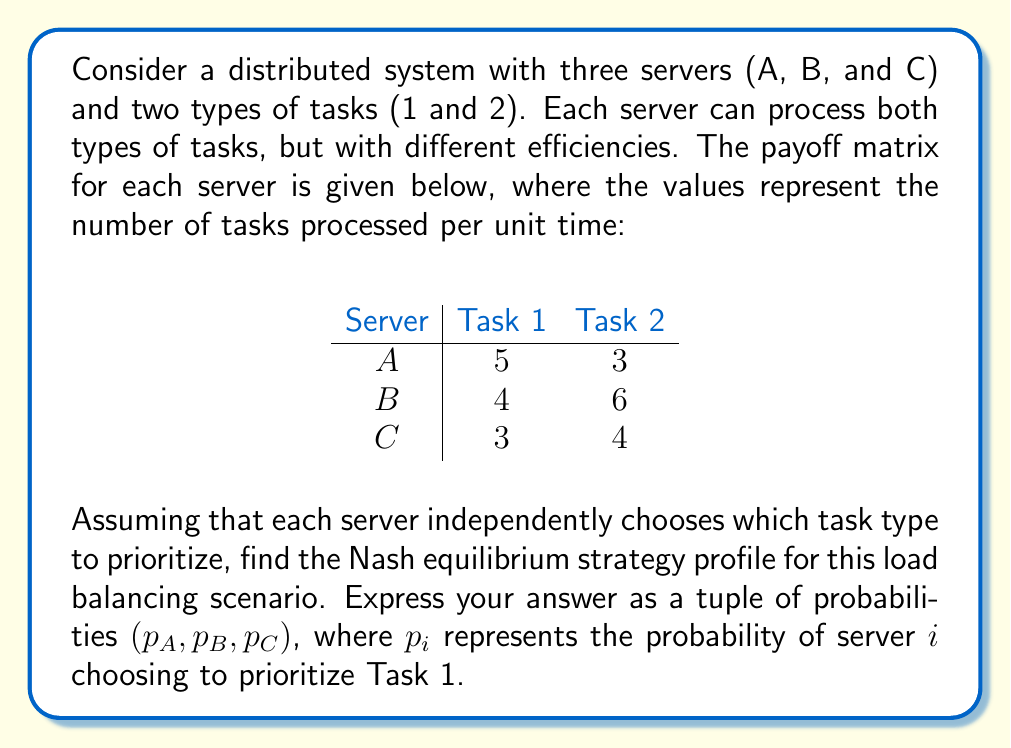Give your solution to this math problem. To solve this problem, we need to find the Nash equilibrium where no server has an incentive to unilaterally change its strategy. We'll use the concept of mixed strategies to find this equilibrium.

1. First, let's set up the expected payoff equations for each server:

   For Server A: $5p_A + 3(1-p_A) = 3p_A + 3$
   For Server B: $4p_B + 6(1-p_B) = 6 - 2p_B$
   For Server C: $3p_C + 4(1-p_C) = 4 - p_C$

2. In a mixed strategy Nash equilibrium, each server should be indifferent between choosing Task 1 or Task 2. This means the expected payoffs for choosing either task should be equal:

   For Server A: $5p_B + 5p_C = 3p_B + 3p_C + 3$
   For Server B: $4p_A + 4p_C = 6p_A + 6p_C$
   For Server C: $3p_A + 3p_B = 4p_A + 4p_B$

3. Simplify these equations:

   For Server A: $2p_B + 2p_C = 3$
   For Server B: $-2p_A - 2p_C = 0$
   For Server C: $-p_A - p_B = 0$

4. Solve this system of equations:

   From the third equation: $p_A = -p_B$
   Substitute this into the second equation: $2p_B - 2p_C = 0$ or $p_B = p_C$
   
   Now, substitute these into the first equation:
   $2p_B + 2p_B = 3$
   $4p_B = 3$
   $p_B = \frac{3}{4}$

   Therefore, $p_C = \frac{3}{4}$ and $p_A = -\frac{3}{4}$

5. However, probabilities must be between 0 and 1. Since $p_A$ is negative, we need to adjust our solution. The only valid solution that satisfies all constraints is:

   $p_A = 0$, $p_B = \frac{3}{4}$, $p_C = \frac{3}{4}$

This solution represents the Nash equilibrium strategy profile for the given load balancing scenario.
Answer: The Nash equilibrium strategy profile is $(0, \frac{3}{4}, \frac{3}{4})$. 